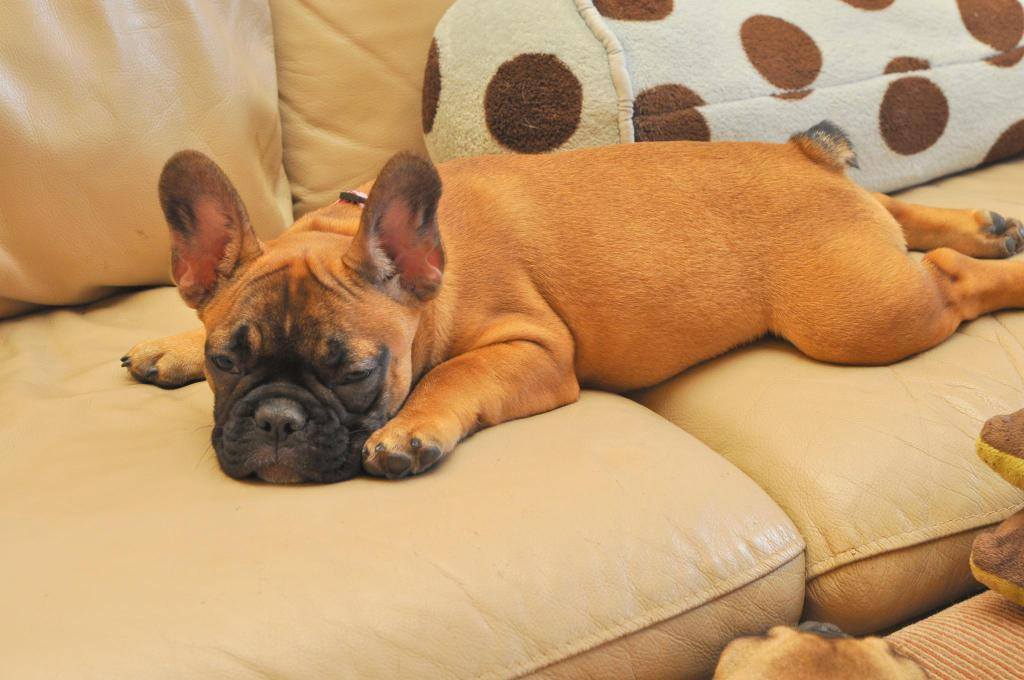What type of animal is on the sofa in the image? There is a dog on the sofa in the image. What other object is visible in the image besides the dog? There is a pillow visible in the image. How many birds are sitting on the dog's head in the image? There are no birds present in the image, so it is not possible to determine how many might be sitting on the dog's head. 